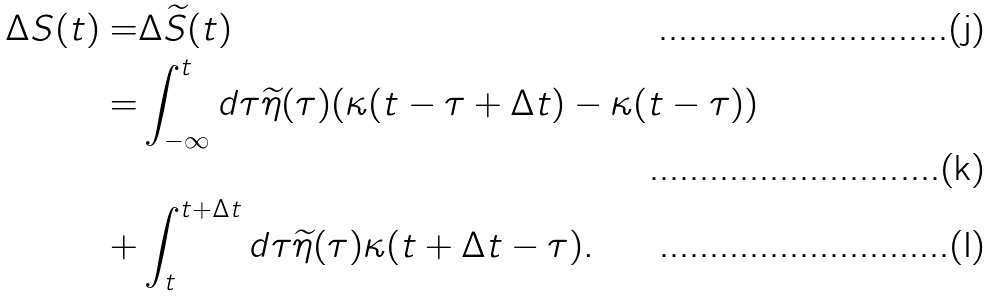<formula> <loc_0><loc_0><loc_500><loc_500>\Delta S ( t ) = & \Delta \widetilde { S } ( t ) \\ = & \int _ { - \infty } ^ { t } d \tau \widetilde { \eta } ( \tau ) ( \kappa ( t - \tau + \Delta t ) - \kappa ( t - \tau ) ) \\ + & \int _ { t } ^ { t + \Delta t } d \tau \widetilde { \eta } ( \tau ) \kappa ( t + \Delta t - \tau ) .</formula> 